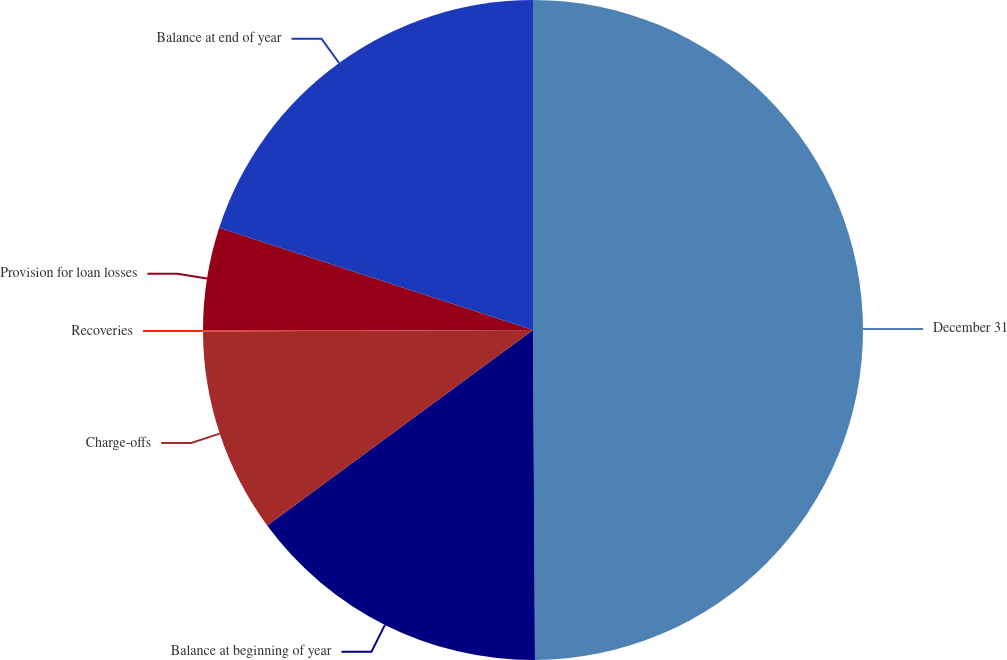Convert chart. <chart><loc_0><loc_0><loc_500><loc_500><pie_chart><fcel>December 31<fcel>Balance at beginning of year<fcel>Charge-offs<fcel>Recoveries<fcel>Provision for loan losses<fcel>Balance at end of year<nl><fcel>49.9%<fcel>15.0%<fcel>10.02%<fcel>0.05%<fcel>5.03%<fcel>19.99%<nl></chart> 